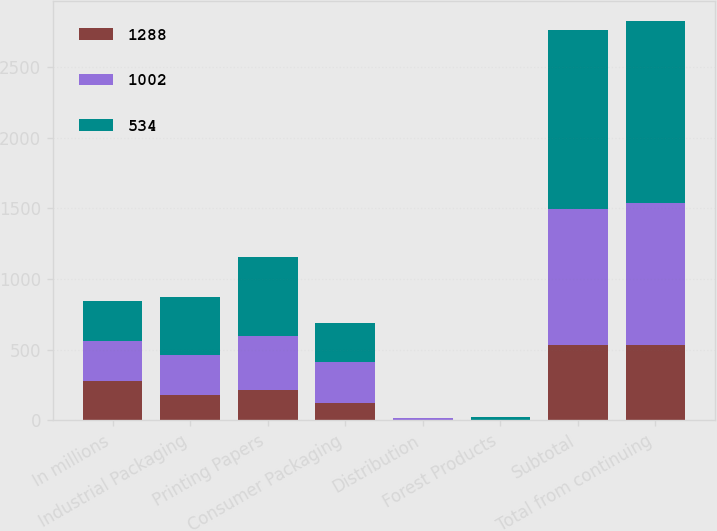Convert chart to OTSL. <chart><loc_0><loc_0><loc_500><loc_500><stacked_bar_chart><ecel><fcel>In millions<fcel>Industrial Packaging<fcel>Printing Papers<fcel>Consumer Packaging<fcel>Distribution<fcel>Forest Products<fcel>Subtotal<fcel>Total from continuing<nl><fcel>1288<fcel>282<fcel>183<fcel>218<fcel>126<fcel>6<fcel>1<fcel>534<fcel>534<nl><fcel>1002<fcel>282<fcel>282<fcel>383<fcel>287<fcel>9<fcel>2<fcel>963<fcel>1002<nl><fcel>534<fcel>282<fcel>405<fcel>556<fcel>276<fcel>6<fcel>22<fcel>1265<fcel>1288<nl></chart> 